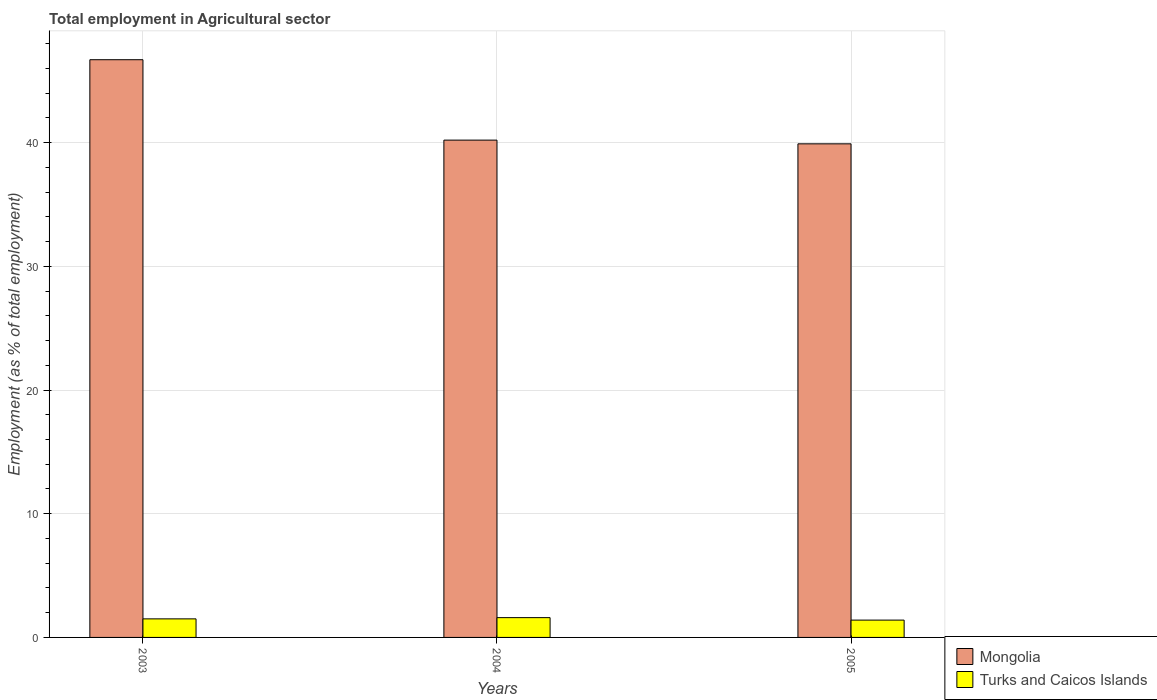In how many cases, is the number of bars for a given year not equal to the number of legend labels?
Offer a very short reply. 0. What is the employment in agricultural sector in Turks and Caicos Islands in 2005?
Offer a terse response. 1.4. Across all years, what is the maximum employment in agricultural sector in Turks and Caicos Islands?
Your answer should be very brief. 1.6. Across all years, what is the minimum employment in agricultural sector in Mongolia?
Ensure brevity in your answer.  39.9. In which year was the employment in agricultural sector in Turks and Caicos Islands maximum?
Offer a terse response. 2004. What is the total employment in agricultural sector in Mongolia in the graph?
Your answer should be compact. 126.8. What is the difference between the employment in agricultural sector in Mongolia in 2004 and that in 2005?
Offer a very short reply. 0.3. What is the difference between the employment in agricultural sector in Turks and Caicos Islands in 2003 and the employment in agricultural sector in Mongolia in 2004?
Keep it short and to the point. -38.7. What is the average employment in agricultural sector in Turks and Caicos Islands per year?
Your response must be concise. 1.5. In the year 2003, what is the difference between the employment in agricultural sector in Turks and Caicos Islands and employment in agricultural sector in Mongolia?
Offer a terse response. -45.2. In how many years, is the employment in agricultural sector in Mongolia greater than 8 %?
Your answer should be compact. 3. What is the ratio of the employment in agricultural sector in Mongolia in 2004 to that in 2005?
Provide a short and direct response. 1.01. What is the difference between the highest and the lowest employment in agricultural sector in Mongolia?
Your answer should be very brief. 6.8. What does the 2nd bar from the left in 2003 represents?
Provide a short and direct response. Turks and Caicos Islands. What does the 2nd bar from the right in 2004 represents?
Provide a succinct answer. Mongolia. How many bars are there?
Offer a terse response. 6. Are the values on the major ticks of Y-axis written in scientific E-notation?
Make the answer very short. No. Does the graph contain any zero values?
Your response must be concise. No. Does the graph contain grids?
Your response must be concise. Yes. What is the title of the graph?
Keep it short and to the point. Total employment in Agricultural sector. What is the label or title of the X-axis?
Provide a succinct answer. Years. What is the label or title of the Y-axis?
Your answer should be very brief. Employment (as % of total employment). What is the Employment (as % of total employment) in Mongolia in 2003?
Provide a succinct answer. 46.7. What is the Employment (as % of total employment) in Turks and Caicos Islands in 2003?
Give a very brief answer. 1.5. What is the Employment (as % of total employment) of Mongolia in 2004?
Keep it short and to the point. 40.2. What is the Employment (as % of total employment) of Turks and Caicos Islands in 2004?
Make the answer very short. 1.6. What is the Employment (as % of total employment) of Mongolia in 2005?
Offer a terse response. 39.9. What is the Employment (as % of total employment) in Turks and Caicos Islands in 2005?
Keep it short and to the point. 1.4. Across all years, what is the maximum Employment (as % of total employment) of Mongolia?
Ensure brevity in your answer.  46.7. Across all years, what is the maximum Employment (as % of total employment) of Turks and Caicos Islands?
Your answer should be compact. 1.6. Across all years, what is the minimum Employment (as % of total employment) of Mongolia?
Offer a very short reply. 39.9. Across all years, what is the minimum Employment (as % of total employment) of Turks and Caicos Islands?
Your answer should be very brief. 1.4. What is the total Employment (as % of total employment) of Mongolia in the graph?
Give a very brief answer. 126.8. What is the total Employment (as % of total employment) of Turks and Caicos Islands in the graph?
Your response must be concise. 4.5. What is the difference between the Employment (as % of total employment) in Mongolia in 2003 and that in 2004?
Provide a succinct answer. 6.5. What is the difference between the Employment (as % of total employment) of Turks and Caicos Islands in 2003 and that in 2004?
Your response must be concise. -0.1. What is the difference between the Employment (as % of total employment) of Mongolia in 2003 and that in 2005?
Keep it short and to the point. 6.8. What is the difference between the Employment (as % of total employment) of Mongolia in 2004 and that in 2005?
Provide a succinct answer. 0.3. What is the difference between the Employment (as % of total employment) of Turks and Caicos Islands in 2004 and that in 2005?
Give a very brief answer. 0.2. What is the difference between the Employment (as % of total employment) of Mongolia in 2003 and the Employment (as % of total employment) of Turks and Caicos Islands in 2004?
Your answer should be compact. 45.1. What is the difference between the Employment (as % of total employment) in Mongolia in 2003 and the Employment (as % of total employment) in Turks and Caicos Islands in 2005?
Keep it short and to the point. 45.3. What is the difference between the Employment (as % of total employment) of Mongolia in 2004 and the Employment (as % of total employment) of Turks and Caicos Islands in 2005?
Keep it short and to the point. 38.8. What is the average Employment (as % of total employment) of Mongolia per year?
Keep it short and to the point. 42.27. What is the average Employment (as % of total employment) in Turks and Caicos Islands per year?
Make the answer very short. 1.5. In the year 2003, what is the difference between the Employment (as % of total employment) of Mongolia and Employment (as % of total employment) of Turks and Caicos Islands?
Your response must be concise. 45.2. In the year 2004, what is the difference between the Employment (as % of total employment) of Mongolia and Employment (as % of total employment) of Turks and Caicos Islands?
Offer a very short reply. 38.6. In the year 2005, what is the difference between the Employment (as % of total employment) of Mongolia and Employment (as % of total employment) of Turks and Caicos Islands?
Offer a very short reply. 38.5. What is the ratio of the Employment (as % of total employment) of Mongolia in 2003 to that in 2004?
Provide a short and direct response. 1.16. What is the ratio of the Employment (as % of total employment) in Turks and Caicos Islands in 2003 to that in 2004?
Offer a terse response. 0.94. What is the ratio of the Employment (as % of total employment) in Mongolia in 2003 to that in 2005?
Make the answer very short. 1.17. What is the ratio of the Employment (as % of total employment) in Turks and Caicos Islands in 2003 to that in 2005?
Make the answer very short. 1.07. What is the ratio of the Employment (as % of total employment) in Mongolia in 2004 to that in 2005?
Offer a terse response. 1.01. What is the difference between the highest and the second highest Employment (as % of total employment) in Mongolia?
Provide a succinct answer. 6.5. What is the difference between the highest and the second highest Employment (as % of total employment) in Turks and Caicos Islands?
Your response must be concise. 0.1. What is the difference between the highest and the lowest Employment (as % of total employment) in Turks and Caicos Islands?
Offer a very short reply. 0.2. 